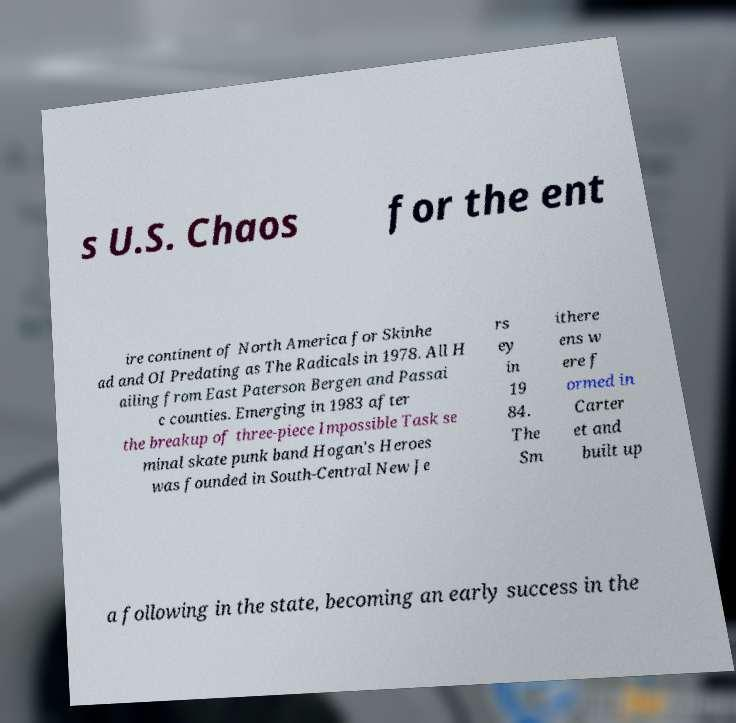Can you read and provide the text displayed in the image?This photo seems to have some interesting text. Can you extract and type it out for me? s U.S. Chaos for the ent ire continent of North America for Skinhe ad and OI Predating as The Radicals in 1978. All H ailing from East Paterson Bergen and Passai c counties. Emerging in 1983 after the breakup of three-piece Impossible Task se minal skate punk band Hogan's Heroes was founded in South-Central New Je rs ey in 19 84. The Sm ithere ens w ere f ormed in Carter et and built up a following in the state, becoming an early success in the 